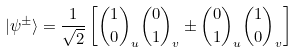Convert formula to latex. <formula><loc_0><loc_0><loc_500><loc_500>| \psi ^ { \pm } \rangle = \frac { 1 } { \sqrt { 2 } } \left [ { 1 \choose 0 } _ { u } { 0 \choose 1 } _ { v } \pm { 0 \choose 1 } _ { u } { 1 \choose 0 } _ { v } \right ]</formula> 